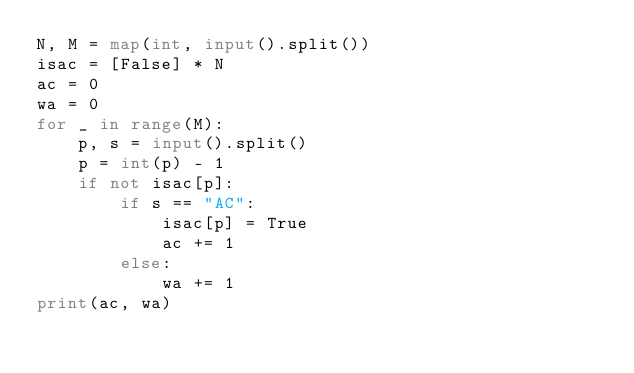<code> <loc_0><loc_0><loc_500><loc_500><_Python_>N, M = map(int, input().split())
isac = [False] * N
ac = 0
wa = 0
for _ in range(M):
    p, s = input().split()
    p = int(p) - 1
    if not isac[p]:
        if s == "AC":
            isac[p] = True
            ac += 1
        else:
            wa += 1
print(ac, wa)</code> 